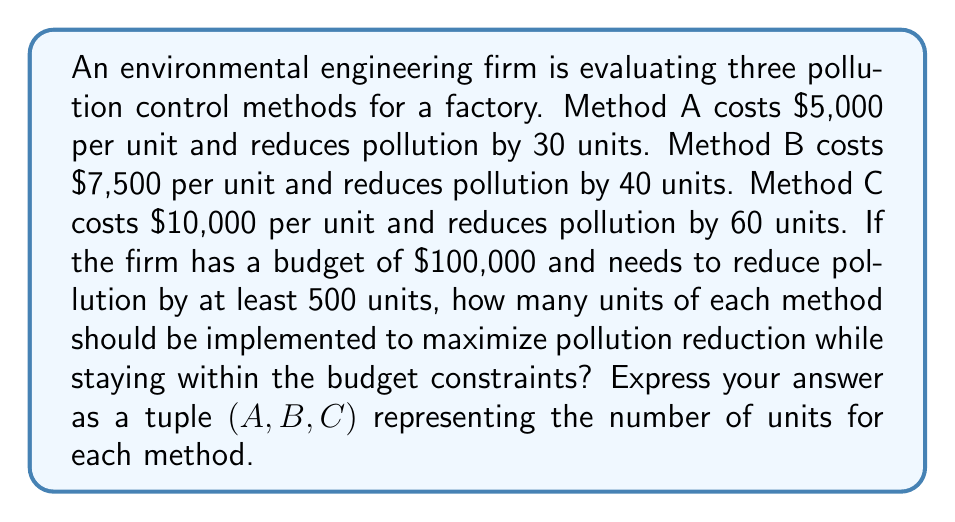Solve this math problem. Let's approach this step-by-step using linear programming:

1) Define variables:
   Let $x$, $y$, and $z$ be the number of units for methods A, B, and C respectively.

2) Set up the objective function:
   Maximize: $30x + 40y + 60z$ (total pollution reduction)

3) Define constraints:
   Budget constraint: $5000x + 7500y + 10000z \leq 100000$
   Minimum pollution reduction: $30x + 40y + 60z \geq 500$
   Non-negativity: $x, y, z \geq 0$ and must be integers

4) Simplify the budget constraint:
   $x + 1.5y + 2z \leq 20$

5) We can solve this using the simplex method, but given the integer constraint, we'll use a more practical approach:

6) Observe that Method C is the most efficient (6 units/$1000), followed by B (5.33 units/$1000), then A (6 units/$1000).

7) Start by maximizing C:
   $10000z \leq 100000$
   $z \leq 10$
   So, we can use 10 units of C, reducing pollution by 600 units and costing $100,000.

8) This solution already meets both constraints, but we need to check if we can do better by using a mix of methods.

9) Try replacing one unit of C with more efficient combinations of A and B:
   Replacing 1C with 2A: 60 pollution reduction, same cost, no improvement.
   Replacing 1C with 1A and 1B: 70 pollution reduction, $2,500 less cost.

10) Optimal solution: 9 units of C, 1 unit of A, and 1 unit of B.
    This reduces pollution by $9(60) + 1(30) + 1(40) = 610$ units
    And costs $9(10000) + 1(5000) + 1(7500) = 100000$
Answer: (1, 1, 9) 